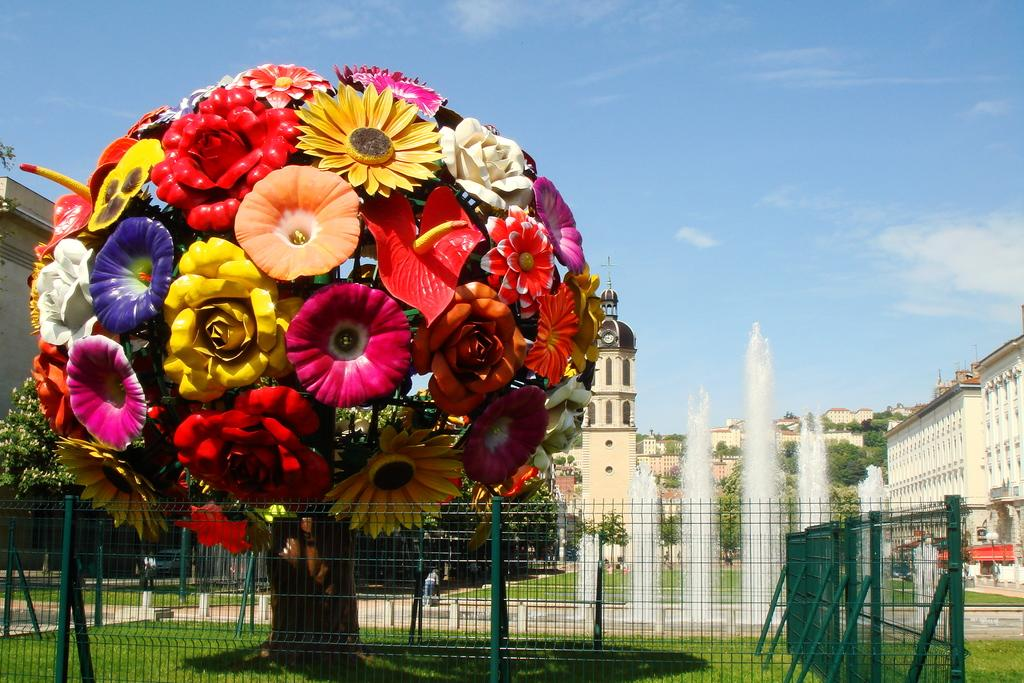What type of fencing can be seen in the image? There are green fences in the image. What is the main feature in the foreground of the image? There is a tree sculpture with huge flowers in the image. What is located behind the tree sculpture? There is a fountain behind the tree sculpture. What can be seen in the background of the image? There are trees and at least one building visible in the background of the image. What is visible at the top of the image? The sky is visible at the top of the image. What type of rail can be seen in the image? There is no rail present in the image. What is the limit of the tree sculpture's growth in the image? The tree sculpture is not a living plant, so it does not have a limit to its growth in the image. 